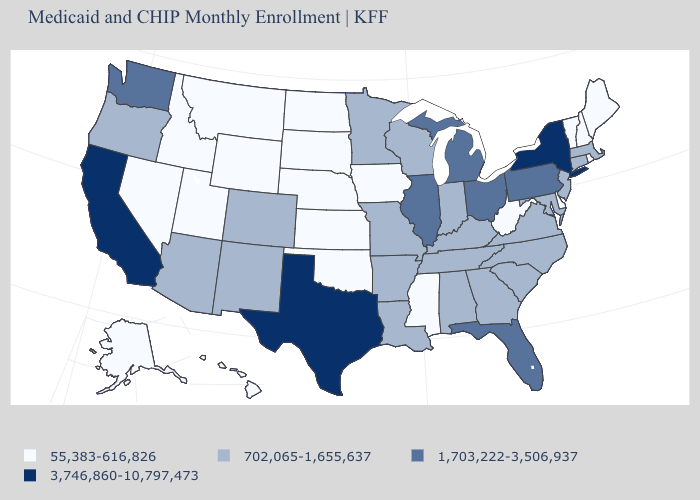Name the states that have a value in the range 55,383-616,826?
Quick response, please. Alaska, Delaware, Hawaii, Idaho, Iowa, Kansas, Maine, Mississippi, Montana, Nebraska, Nevada, New Hampshire, North Dakota, Oklahoma, Rhode Island, South Dakota, Utah, Vermont, West Virginia, Wyoming. Name the states that have a value in the range 55,383-616,826?
Quick response, please. Alaska, Delaware, Hawaii, Idaho, Iowa, Kansas, Maine, Mississippi, Montana, Nebraska, Nevada, New Hampshire, North Dakota, Oklahoma, Rhode Island, South Dakota, Utah, Vermont, West Virginia, Wyoming. Does North Carolina have a lower value than Illinois?
Quick response, please. Yes. Which states have the highest value in the USA?
Write a very short answer. California, New York, Texas. What is the highest value in the MidWest ?
Give a very brief answer. 1,703,222-3,506,937. Does Montana have a lower value than Oklahoma?
Be succinct. No. Name the states that have a value in the range 55,383-616,826?
Give a very brief answer. Alaska, Delaware, Hawaii, Idaho, Iowa, Kansas, Maine, Mississippi, Montana, Nebraska, Nevada, New Hampshire, North Dakota, Oklahoma, Rhode Island, South Dakota, Utah, Vermont, West Virginia, Wyoming. Among the states that border New York , which have the lowest value?
Quick response, please. Vermont. Name the states that have a value in the range 55,383-616,826?
Answer briefly. Alaska, Delaware, Hawaii, Idaho, Iowa, Kansas, Maine, Mississippi, Montana, Nebraska, Nevada, New Hampshire, North Dakota, Oklahoma, Rhode Island, South Dakota, Utah, Vermont, West Virginia, Wyoming. Among the states that border Minnesota , which have the highest value?
Give a very brief answer. Wisconsin. Among the states that border Maryland , which have the highest value?
Keep it brief. Pennsylvania. Does the first symbol in the legend represent the smallest category?
Short answer required. Yes. What is the lowest value in states that border Delaware?
Be succinct. 702,065-1,655,637. Among the states that border Delaware , which have the lowest value?
Give a very brief answer. Maryland, New Jersey. How many symbols are there in the legend?
Short answer required. 4. 